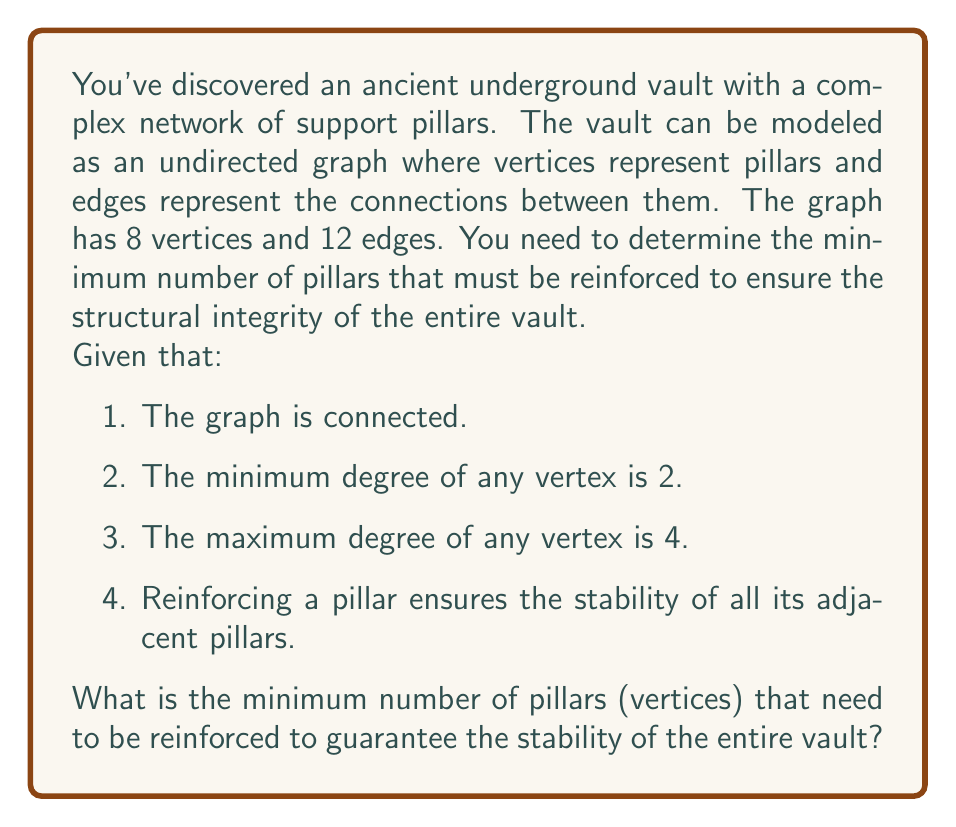Provide a solution to this math problem. To solve this problem, we need to find the minimum dominating set of the graph. A dominating set is a subset of vertices such that every vertex in the graph is either in the set or adjacent to a vertex in the set.

Let's approach this step-by-step:

1. First, we know that the graph has 8 vertices and 12 edges. This suggests a moderately dense graph.

2. The minimum degree of 2 and maximum degree of 4 indicate that each pillar is connected to at least 2 and at most 4 other pillars.

3. To find the minimum dominating set, we can use the following inequality:

   $$\gamma(G) \leq \frac{n}{1+\delta(G)}$$

   Where $\gamma(G)$ is the domination number (size of the minimum dominating set), $n$ is the number of vertices, and $\delta(G)$ is the minimum degree of the graph.

4. In this case:
   $n = 8$
   $\delta(G) = 2$

5. Applying the formula:

   $$\gamma(G) \leq \frac{8}{1+2} = \frac{8}{3} \approx 2.67$$

6. Since $\gamma(G)$ must be an integer, we round up to get an upper bound of 3.

7. Now, let's consider the structure of the graph. With 8 vertices and a maximum degree of 4, it's impossible for a single vertex to dominate the entire graph.

8. However, given the density of the graph (12 edges for 8 vertices), it's likely that two well-chosen vertices could dominate the graph.

9. To verify this, we can consider that in the worst case, two vertices of degree 4 could potentially cover up to 6 unique vertices (excluding themselves), plus themselves, totaling 8 vertices.

Therefore, the minimum number of pillars that need to be reinforced is 2.
Answer: 2 pillars 